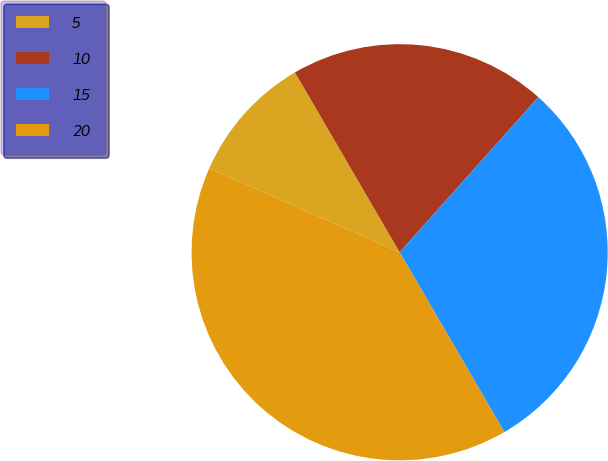<chart> <loc_0><loc_0><loc_500><loc_500><pie_chart><fcel>5<fcel>10<fcel>15<fcel>20<nl><fcel>10.0%<fcel>20.0%<fcel>30.0%<fcel>40.0%<nl></chart> 